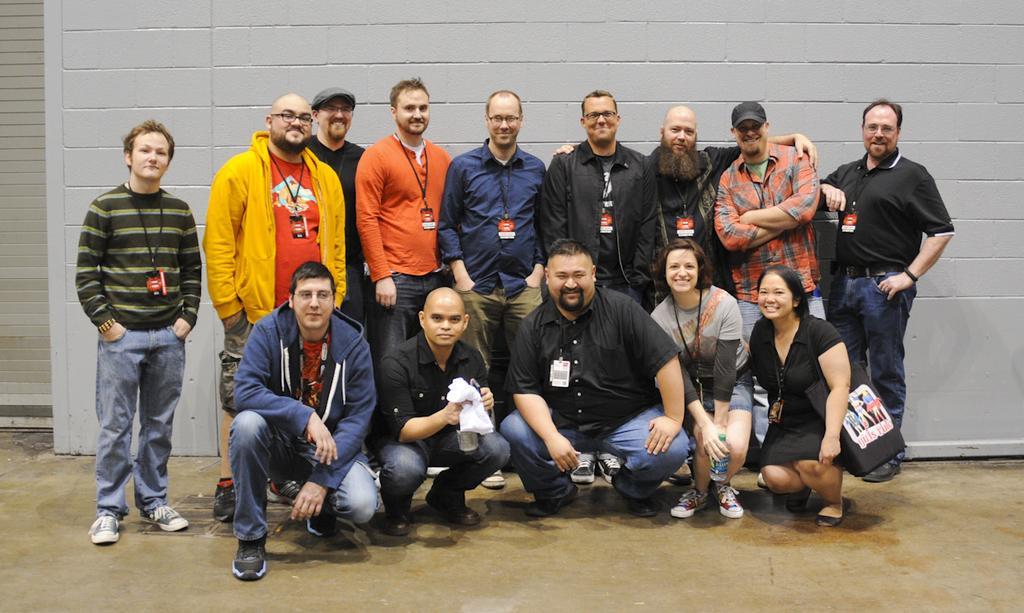Can you describe this image briefly? In this picture I can see a group of people among them some are standing and some are sitting. In the background I can see a white color wall. Among these people I can see some are wearing caps and smiling. On the left side I can see a woman is carrying a bag. 